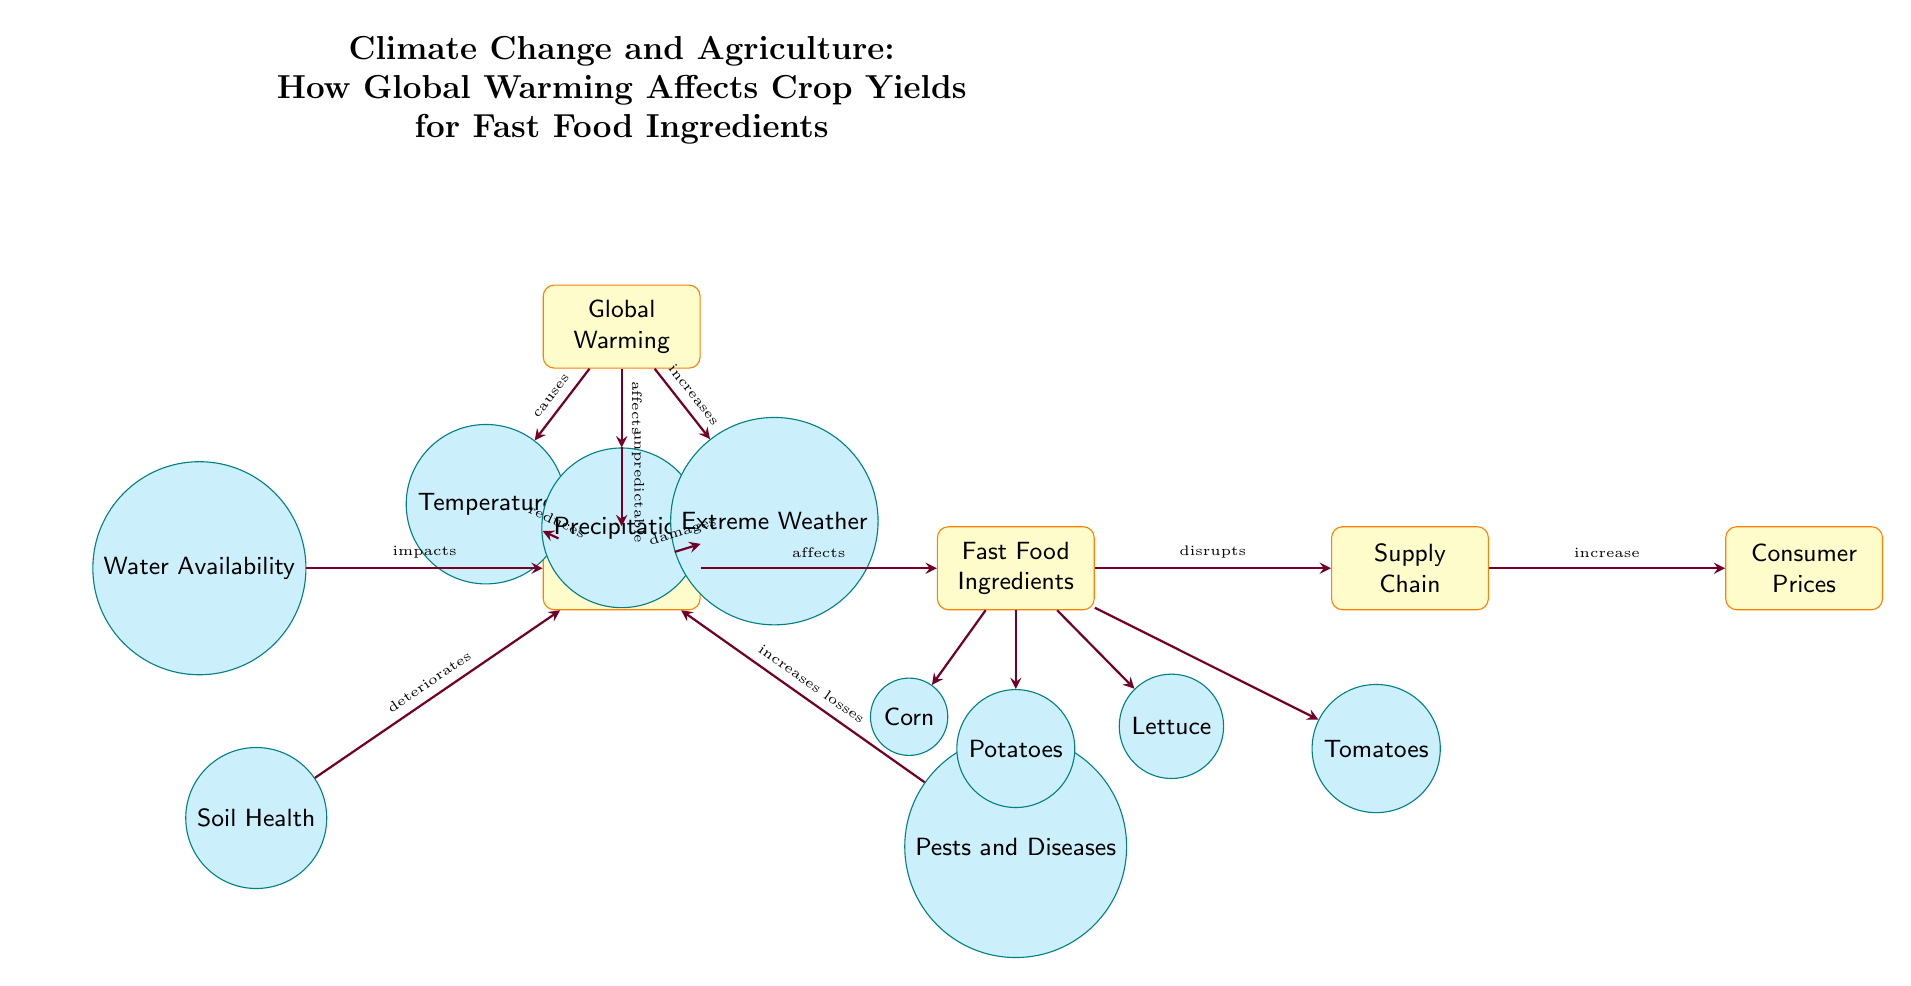What is the main cause of crop yield reduction? The diagram indicates that "Temperature" is affected by "Global Warming," which subsequently "reduces" "Crop Yields." Therefore, the primary cause of crop yield reduction, as depicted, is temperature.
Answer: Temperature How many fast food ingredients are shown? The diagram lists four specific fast food ingredients: Corn, Potatoes, Lettuce, and Tomatoes directly associated with the "Fast Food Ingredients" node. Counting these gives a total of four ingredients.
Answer: Four What does extreme weather do to crop yields? The arrow leads from "Extreme Weather" to "Crop Yields," labeled with the word "damages," indicating that extreme weather has a damaging effect on crop yields.
Answer: Damages Which factors increase crop yield losses? The diagram presents "Pests and Diseases," which has an arrow pointing to "Crop Yields" labeled "increases losses." Hence, pests and diseases are factors that specifically increase crop yield losses.
Answer: Pests and Diseases How does crop yield impact consumer prices? The diagram demonstrates that "Crop Yields" affects "Fast Food Ingredients," which then disrupts the "Supply Chain," ultimately resulting in an increase in "Consumer Prices." This highlights the indirect relationship from crop yields to consumer prices through the supply chain.
Answer: Increases What is the relationship between soil health and crop yields? The diagram illustrates that "Soil Health" affects "Crop Yields" with the label "deteriorates." This shows that the condition of soil health deteriorates crop yields, indicating a negative relationship.
Answer: Deteriorates How does global warming affect precipitation? An arrow connects "Global Warming" to "Precipitation," labelled with the word "affects." This indicates that one of the impacts of global warming is a change to precipitation patterns.
Answer: Affects Which node is directly affected by "Water Availability"? The diagram shows an arrow from "Water Availability" directed towards "Crop Yields" with the label "impacts." Thus, "Crop Yields" is the node directly affected by water availability.
Answer: Crop Yields 